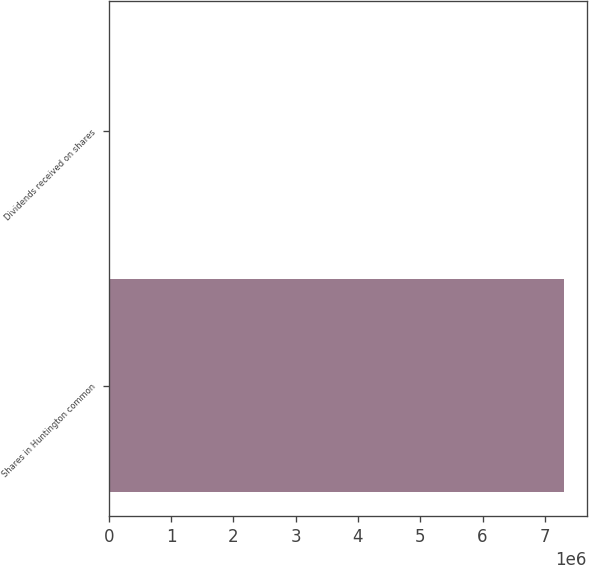<chart> <loc_0><loc_0><loc_500><loc_500><bar_chart><fcel>Shares in Huntington common<fcel>Dividends received on shares<nl><fcel>7.30999e+06<fcel>0.4<nl></chart> 